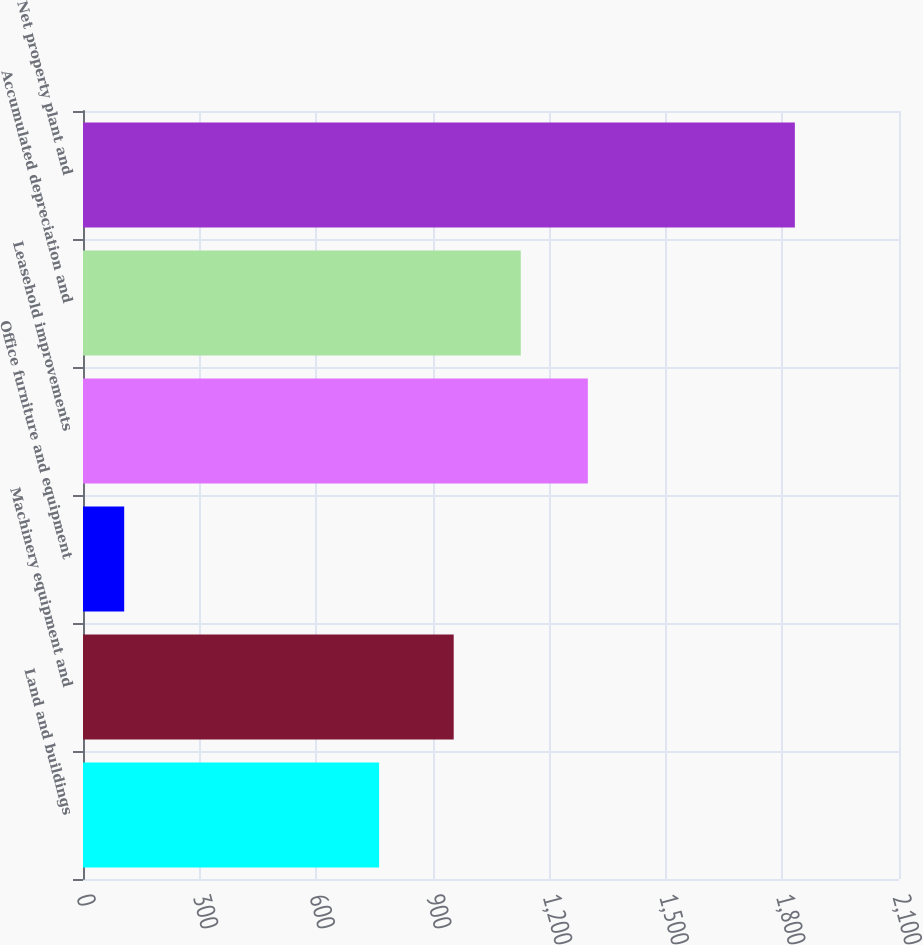<chart> <loc_0><loc_0><loc_500><loc_500><bar_chart><fcel>Land and buildings<fcel>Machinery equipment and<fcel>Office furniture and equipment<fcel>Leasehold improvements<fcel>Accumulated depreciation and<fcel>Net property plant and<nl><fcel>762<fcel>954<fcel>106<fcel>1299.2<fcel>1126.6<fcel>1832<nl></chart> 